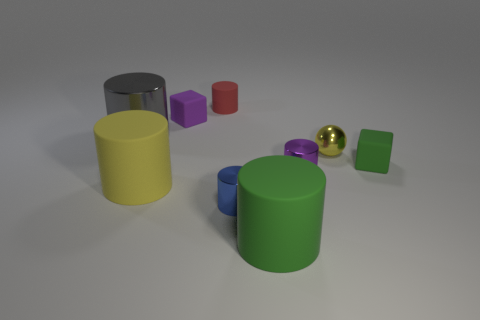Subtract all big gray cylinders. How many cylinders are left? 5 Subtract all yellow cylinders. How many cylinders are left? 5 Add 1 green matte cylinders. How many objects exist? 10 Subtract all cylinders. How many objects are left? 3 Subtract all gray cylinders. Subtract all red blocks. How many cylinders are left? 5 Subtract all small blue metallic cylinders. Subtract all tiny blue metal cylinders. How many objects are left? 7 Add 7 tiny blocks. How many tiny blocks are left? 9 Add 4 rubber things. How many rubber things exist? 9 Subtract 0 brown cylinders. How many objects are left? 9 